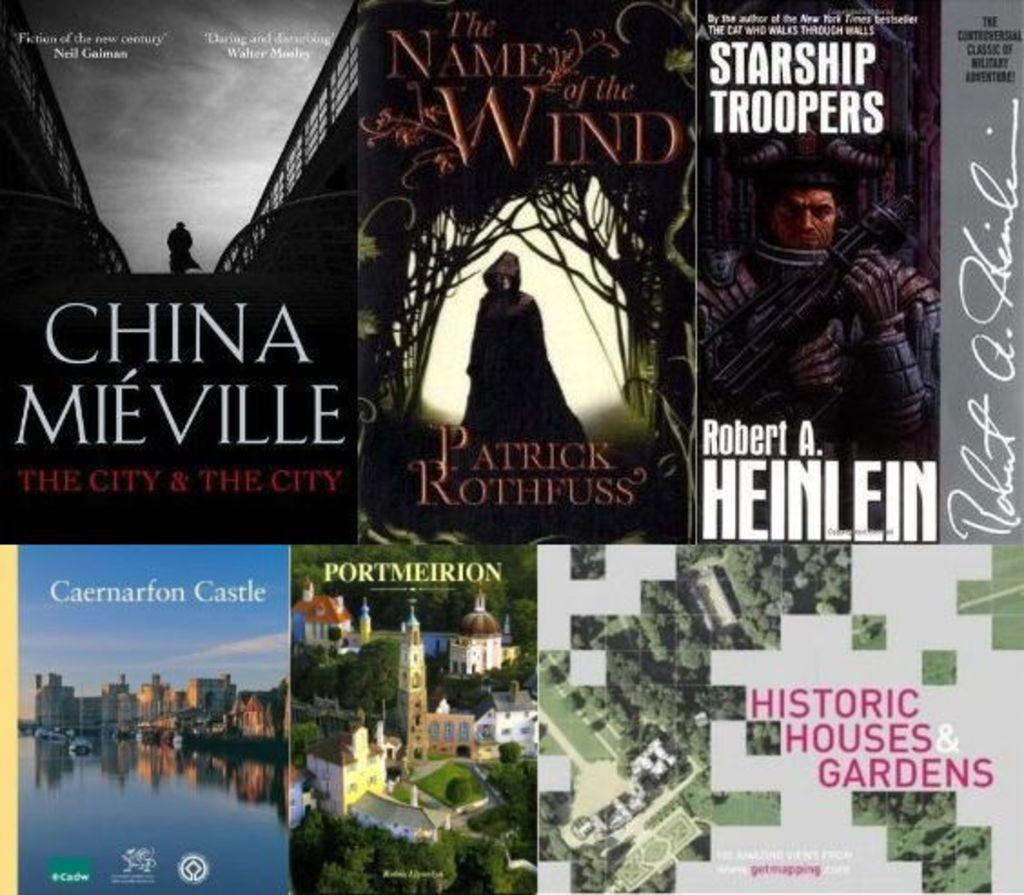<image>
Create a compact narrative representing the image presented. many books are side by side including one called The name of the wind 